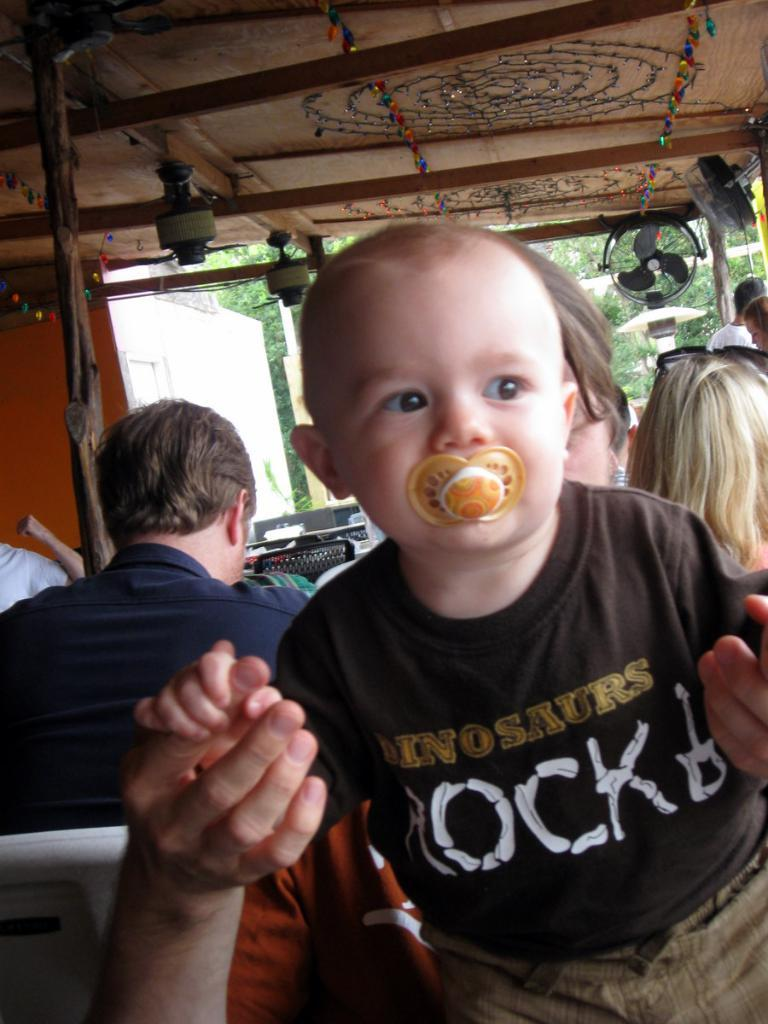How many people are in the image? There are persons in the image, but the exact number is not specified. What can be seen on the roof in the image? There are objects attached to the roof in the image. Can you describe any other objects in the image? Yes, there are other objects in the image, but their specific details are not provided. What type of natural environment is visible in the image? There are many trees in the image, suggesting a forest or wooded area. What type of bean is being harvested in the image? There is no bean or bean harvesting activity present in the image. What type of operation is being performed on the tree in the image? There is no operation or tree visible in the image. 